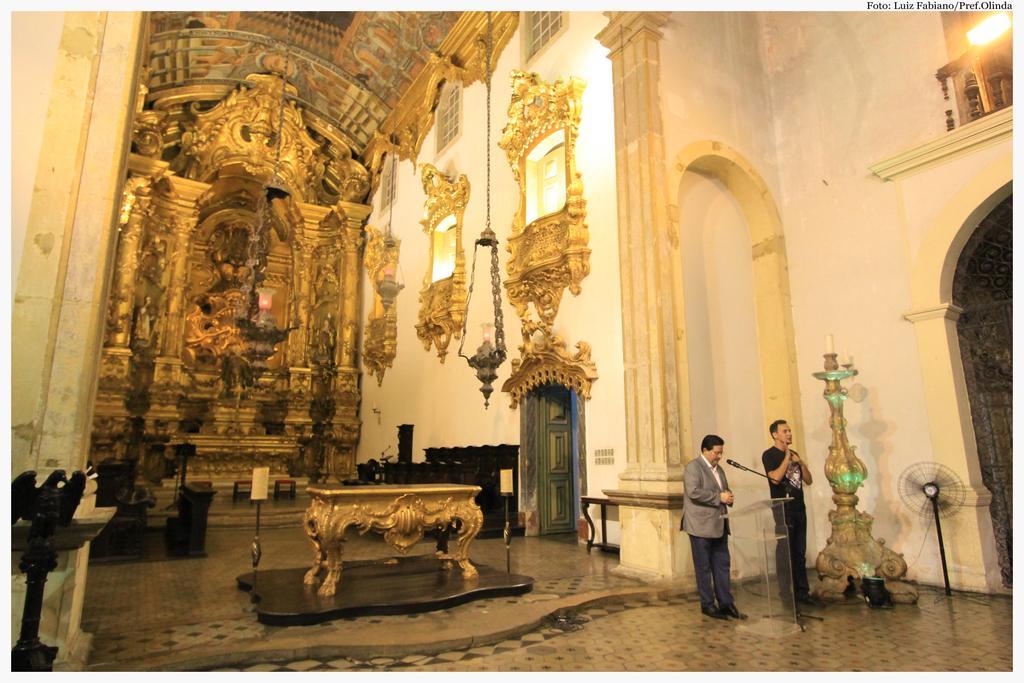Please provide a concise description of this image. In this picture we can see inside view of a building, here we can see a floor, on this floor we can see people, podium, mics, fan, door and some objects and in the background we can see a wall, lights. 